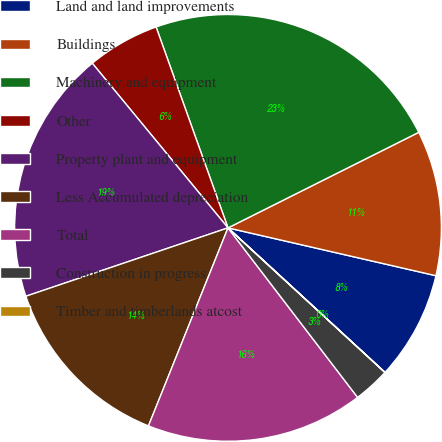Convert chart to OTSL. <chart><loc_0><loc_0><loc_500><loc_500><pie_chart><fcel>Land and land improvements<fcel>Buildings<fcel>Machinery and equipment<fcel>Other<fcel>Property plant and equipment<fcel>Less Accumulated depreciation<fcel>Total<fcel>Construction in progress<fcel>Timber and timberlands atcost<nl><fcel>8.24%<fcel>10.99%<fcel>23.08%<fcel>5.5%<fcel>19.22%<fcel>13.73%<fcel>16.47%<fcel>2.76%<fcel>0.01%<nl></chart> 